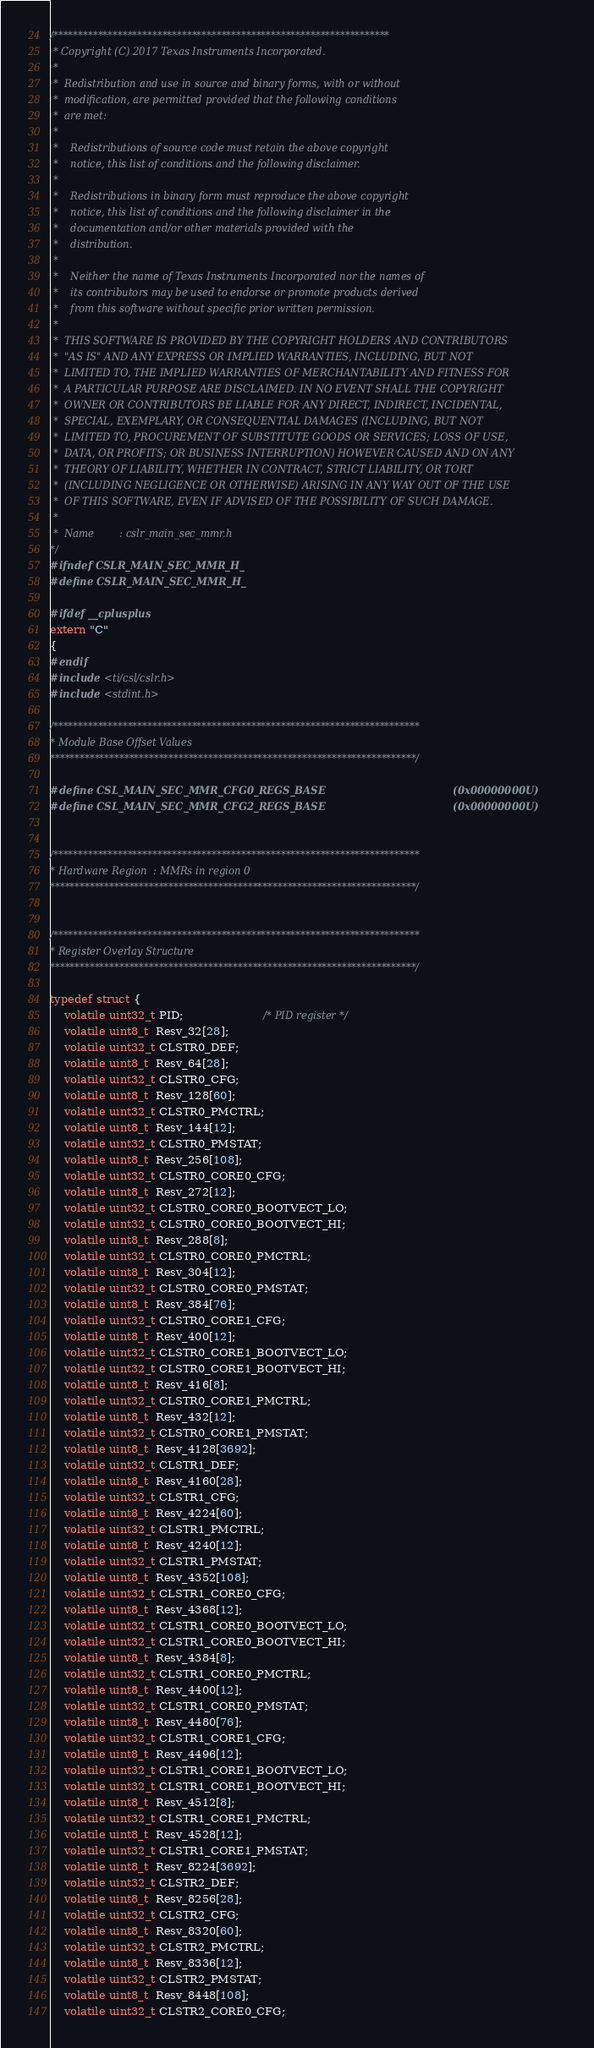Convert code to text. <code><loc_0><loc_0><loc_500><loc_500><_C_>/********************************************************************
 * Copyright (C) 2017 Texas Instruments Incorporated.
 *
 *  Redistribution and use in source and binary forms, with or without
 *  modification, are permitted provided that the following conditions
 *  are met:
 *
 *    Redistributions of source code must retain the above copyright
 *    notice, this list of conditions and the following disclaimer.
 *
 *    Redistributions in binary form must reproduce the above copyright
 *    notice, this list of conditions and the following disclaimer in the
 *    documentation and/or other materials provided with the
 *    distribution.
 *
 *    Neither the name of Texas Instruments Incorporated nor the names of
 *    its contributors may be used to endorse or promote products derived
 *    from this software without specific prior written permission.
 *
 *  THIS SOFTWARE IS PROVIDED BY THE COPYRIGHT HOLDERS AND CONTRIBUTORS
 *  "AS IS" AND ANY EXPRESS OR IMPLIED WARRANTIES, INCLUDING, BUT NOT
 *  LIMITED TO, THE IMPLIED WARRANTIES OF MERCHANTABILITY AND FITNESS FOR
 *  A PARTICULAR PURPOSE ARE DISCLAIMED. IN NO EVENT SHALL THE COPYRIGHT
 *  OWNER OR CONTRIBUTORS BE LIABLE FOR ANY DIRECT, INDIRECT, INCIDENTAL,
 *  SPECIAL, EXEMPLARY, OR CONSEQUENTIAL DAMAGES (INCLUDING, BUT NOT
 *  LIMITED TO, PROCUREMENT OF SUBSTITUTE GOODS OR SERVICES; LOSS OF USE,
 *  DATA, OR PROFITS; OR BUSINESS INTERRUPTION) HOWEVER CAUSED AND ON ANY
 *  THEORY OF LIABILITY, WHETHER IN CONTRACT, STRICT LIABILITY, OR TORT
 *  (INCLUDING NEGLIGENCE OR OTHERWISE) ARISING IN ANY WAY OUT OF THE USE
 *  OF THIS SOFTWARE, EVEN IF ADVISED OF THE POSSIBILITY OF SUCH DAMAGE.
 *
 *  Name        : cslr_main_sec_mmr.h
*/
#ifndef CSLR_MAIN_SEC_MMR_H_
#define CSLR_MAIN_SEC_MMR_H_

#ifdef __cplusplus
extern "C"
{
#endif
#include <ti/csl/cslr.h>
#include <stdint.h>

/**************************************************************************
* Module Base Offset Values
**************************************************************************/

#define CSL_MAIN_SEC_MMR_CFG0_REGS_BASE                                     (0x00000000U)
#define CSL_MAIN_SEC_MMR_CFG2_REGS_BASE                                     (0x00000000U)


/**************************************************************************
* Hardware Region  : MMRs in region 0
**************************************************************************/


/**************************************************************************
* Register Overlay Structure
**************************************************************************/

typedef struct {
    volatile uint32_t PID;                       /* PID register */
    volatile uint8_t  Resv_32[28];
    volatile uint32_t CLSTR0_DEF;
    volatile uint8_t  Resv_64[28];
    volatile uint32_t CLSTR0_CFG;
    volatile uint8_t  Resv_128[60];
    volatile uint32_t CLSTR0_PMCTRL;
    volatile uint8_t  Resv_144[12];
    volatile uint32_t CLSTR0_PMSTAT;
    volatile uint8_t  Resv_256[108];
    volatile uint32_t CLSTR0_CORE0_CFG;
    volatile uint8_t  Resv_272[12];
    volatile uint32_t CLSTR0_CORE0_BOOTVECT_LO;
    volatile uint32_t CLSTR0_CORE0_BOOTVECT_HI;
    volatile uint8_t  Resv_288[8];
    volatile uint32_t CLSTR0_CORE0_PMCTRL;
    volatile uint8_t  Resv_304[12];
    volatile uint32_t CLSTR0_CORE0_PMSTAT;
    volatile uint8_t  Resv_384[76];
    volatile uint32_t CLSTR0_CORE1_CFG;
    volatile uint8_t  Resv_400[12];
    volatile uint32_t CLSTR0_CORE1_BOOTVECT_LO;
    volatile uint32_t CLSTR0_CORE1_BOOTVECT_HI;
    volatile uint8_t  Resv_416[8];
    volatile uint32_t CLSTR0_CORE1_PMCTRL;
    volatile uint8_t  Resv_432[12];
    volatile uint32_t CLSTR0_CORE1_PMSTAT;
    volatile uint8_t  Resv_4128[3692];
    volatile uint32_t CLSTR1_DEF;
    volatile uint8_t  Resv_4160[28];
    volatile uint32_t CLSTR1_CFG;
    volatile uint8_t  Resv_4224[60];
    volatile uint32_t CLSTR1_PMCTRL;
    volatile uint8_t  Resv_4240[12];
    volatile uint32_t CLSTR1_PMSTAT;
    volatile uint8_t  Resv_4352[108];
    volatile uint32_t CLSTR1_CORE0_CFG;
    volatile uint8_t  Resv_4368[12];
    volatile uint32_t CLSTR1_CORE0_BOOTVECT_LO;
    volatile uint32_t CLSTR1_CORE0_BOOTVECT_HI;
    volatile uint8_t  Resv_4384[8];
    volatile uint32_t CLSTR1_CORE0_PMCTRL;
    volatile uint8_t  Resv_4400[12];
    volatile uint32_t CLSTR1_CORE0_PMSTAT;
    volatile uint8_t  Resv_4480[76];
    volatile uint32_t CLSTR1_CORE1_CFG;
    volatile uint8_t  Resv_4496[12];
    volatile uint32_t CLSTR1_CORE1_BOOTVECT_LO;
    volatile uint32_t CLSTR1_CORE1_BOOTVECT_HI;
    volatile uint8_t  Resv_4512[8];
    volatile uint32_t CLSTR1_CORE1_PMCTRL;
    volatile uint8_t  Resv_4528[12];
    volatile uint32_t CLSTR1_CORE1_PMSTAT;
    volatile uint8_t  Resv_8224[3692];
    volatile uint32_t CLSTR2_DEF;
    volatile uint8_t  Resv_8256[28];
    volatile uint32_t CLSTR2_CFG;
    volatile uint8_t  Resv_8320[60];
    volatile uint32_t CLSTR2_PMCTRL;
    volatile uint8_t  Resv_8336[12];
    volatile uint32_t CLSTR2_PMSTAT;
    volatile uint8_t  Resv_8448[108];
    volatile uint32_t CLSTR2_CORE0_CFG;</code> 